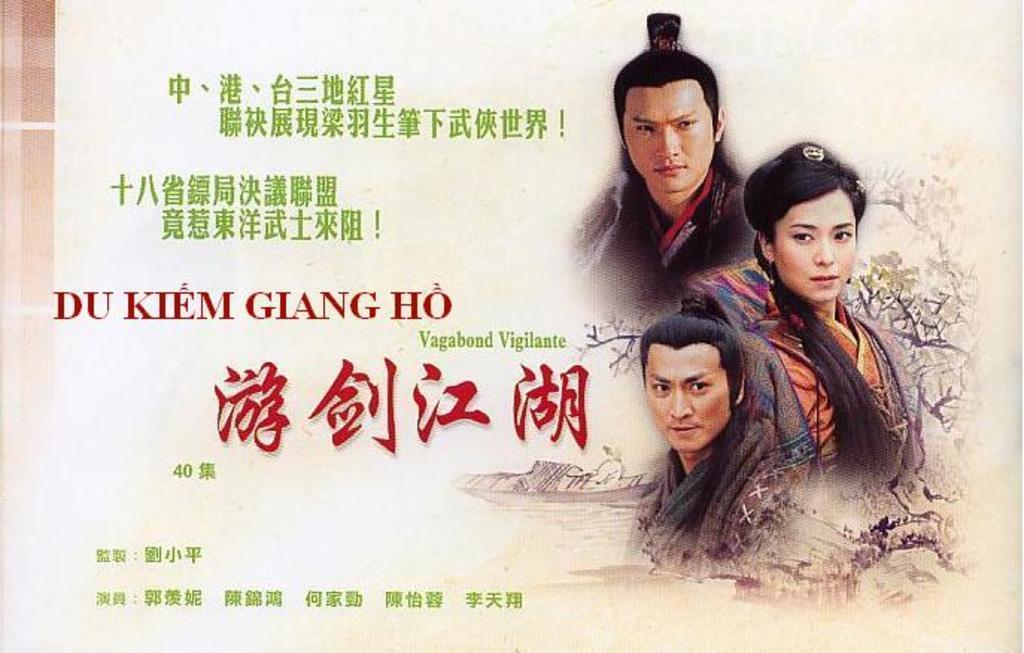Please provide a concise description of this image. This is a picture of a poster. We can see the people and some information. 